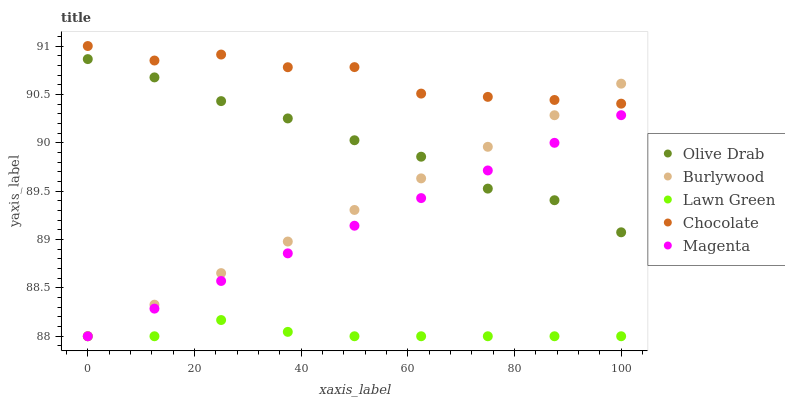Does Lawn Green have the minimum area under the curve?
Answer yes or no. Yes. Does Chocolate have the maximum area under the curve?
Answer yes or no. Yes. Does Magenta have the minimum area under the curve?
Answer yes or no. No. Does Magenta have the maximum area under the curve?
Answer yes or no. No. Is Magenta the smoothest?
Answer yes or no. Yes. Is Chocolate the roughest?
Answer yes or no. Yes. Is Lawn Green the smoothest?
Answer yes or no. No. Is Lawn Green the roughest?
Answer yes or no. No. Does Burlywood have the lowest value?
Answer yes or no. Yes. Does Olive Drab have the lowest value?
Answer yes or no. No. Does Chocolate have the highest value?
Answer yes or no. Yes. Does Magenta have the highest value?
Answer yes or no. No. Is Lawn Green less than Olive Drab?
Answer yes or no. Yes. Is Olive Drab greater than Lawn Green?
Answer yes or no. Yes. Does Lawn Green intersect Burlywood?
Answer yes or no. Yes. Is Lawn Green less than Burlywood?
Answer yes or no. No. Is Lawn Green greater than Burlywood?
Answer yes or no. No. Does Lawn Green intersect Olive Drab?
Answer yes or no. No. 